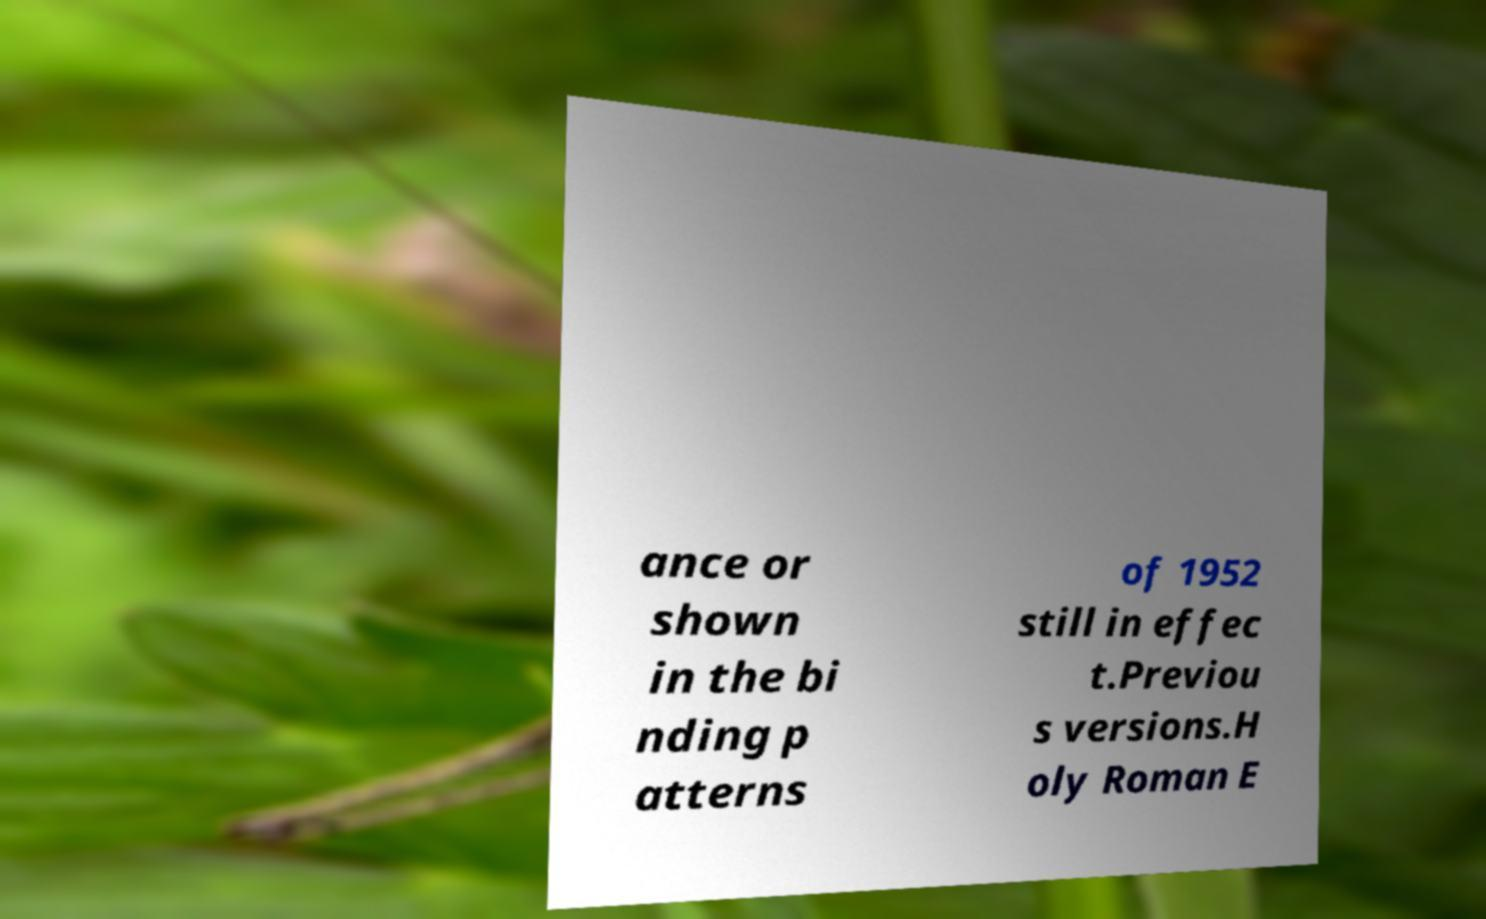What messages or text are displayed in this image? I need them in a readable, typed format. ance or shown in the bi nding p atterns of 1952 still in effec t.Previou s versions.H oly Roman E 